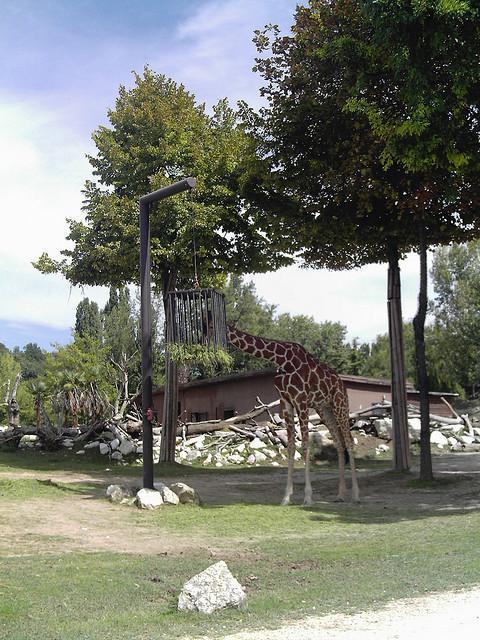How many people are holding signs?
Give a very brief answer. 0. 